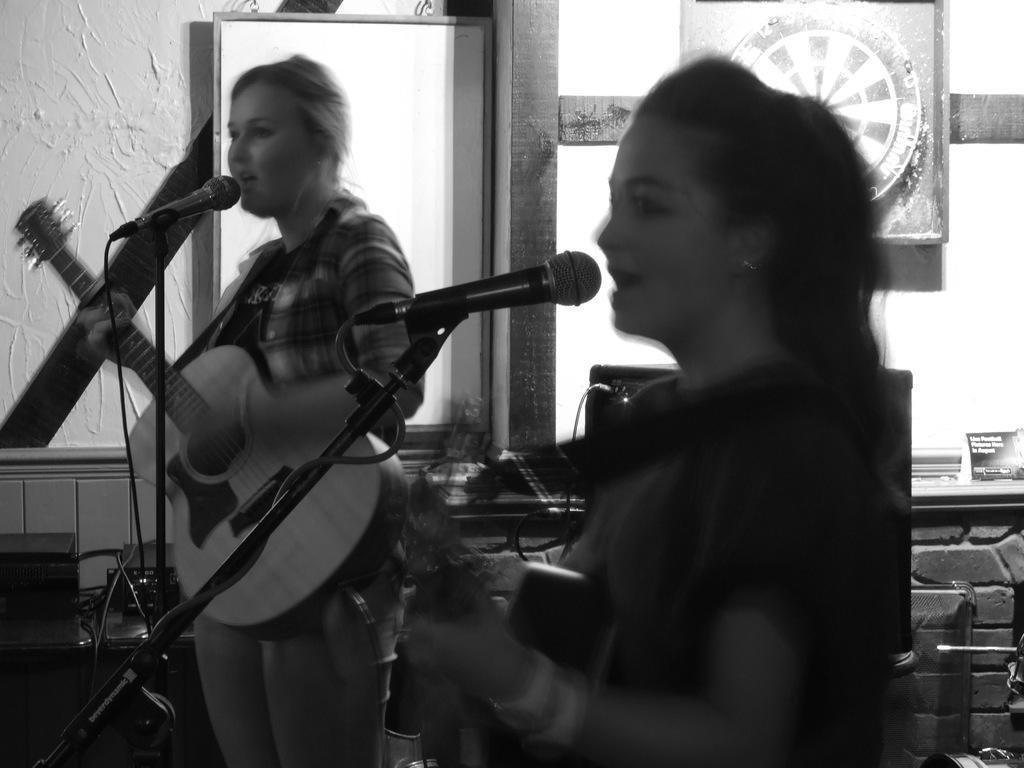Describe this image in one or two sentences. This is completely a black and white picture. Here we can see two women standing in front of a mike , singing and playing guitars. On the background we can see a wall, white board and here we can see aboard. 